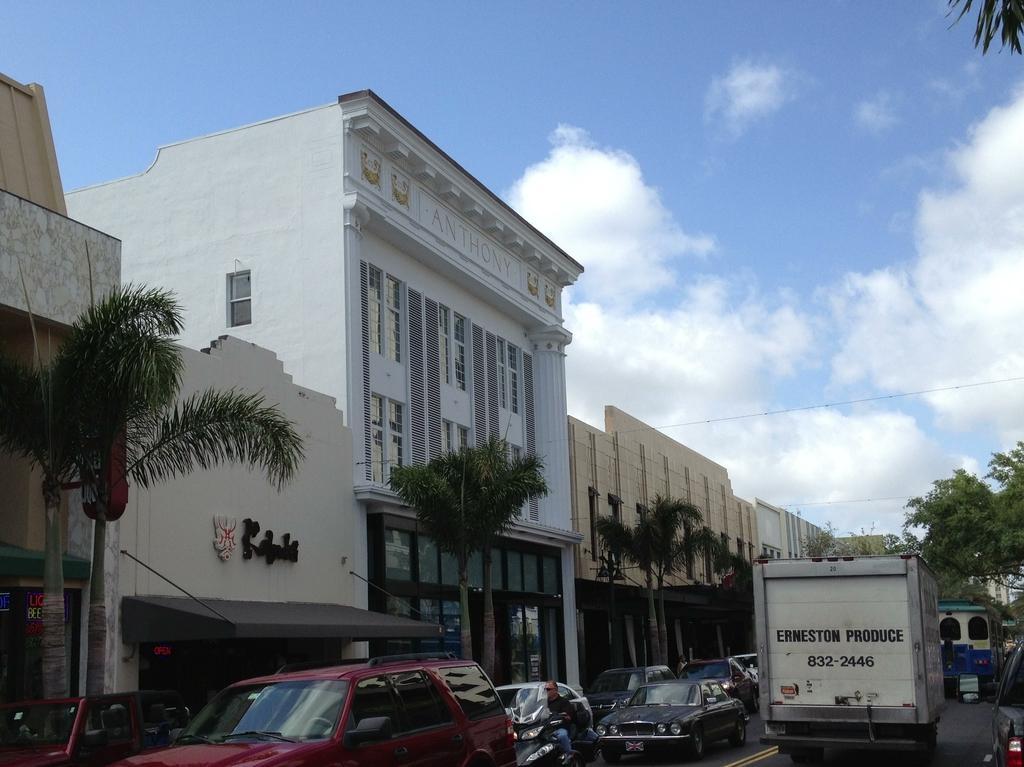In one or two sentences, can you explain what this image depicts? In this image, there are a few buildings, trees, vehicles. We can see the ground and a person. We can see some wires and the sky with clouds. 